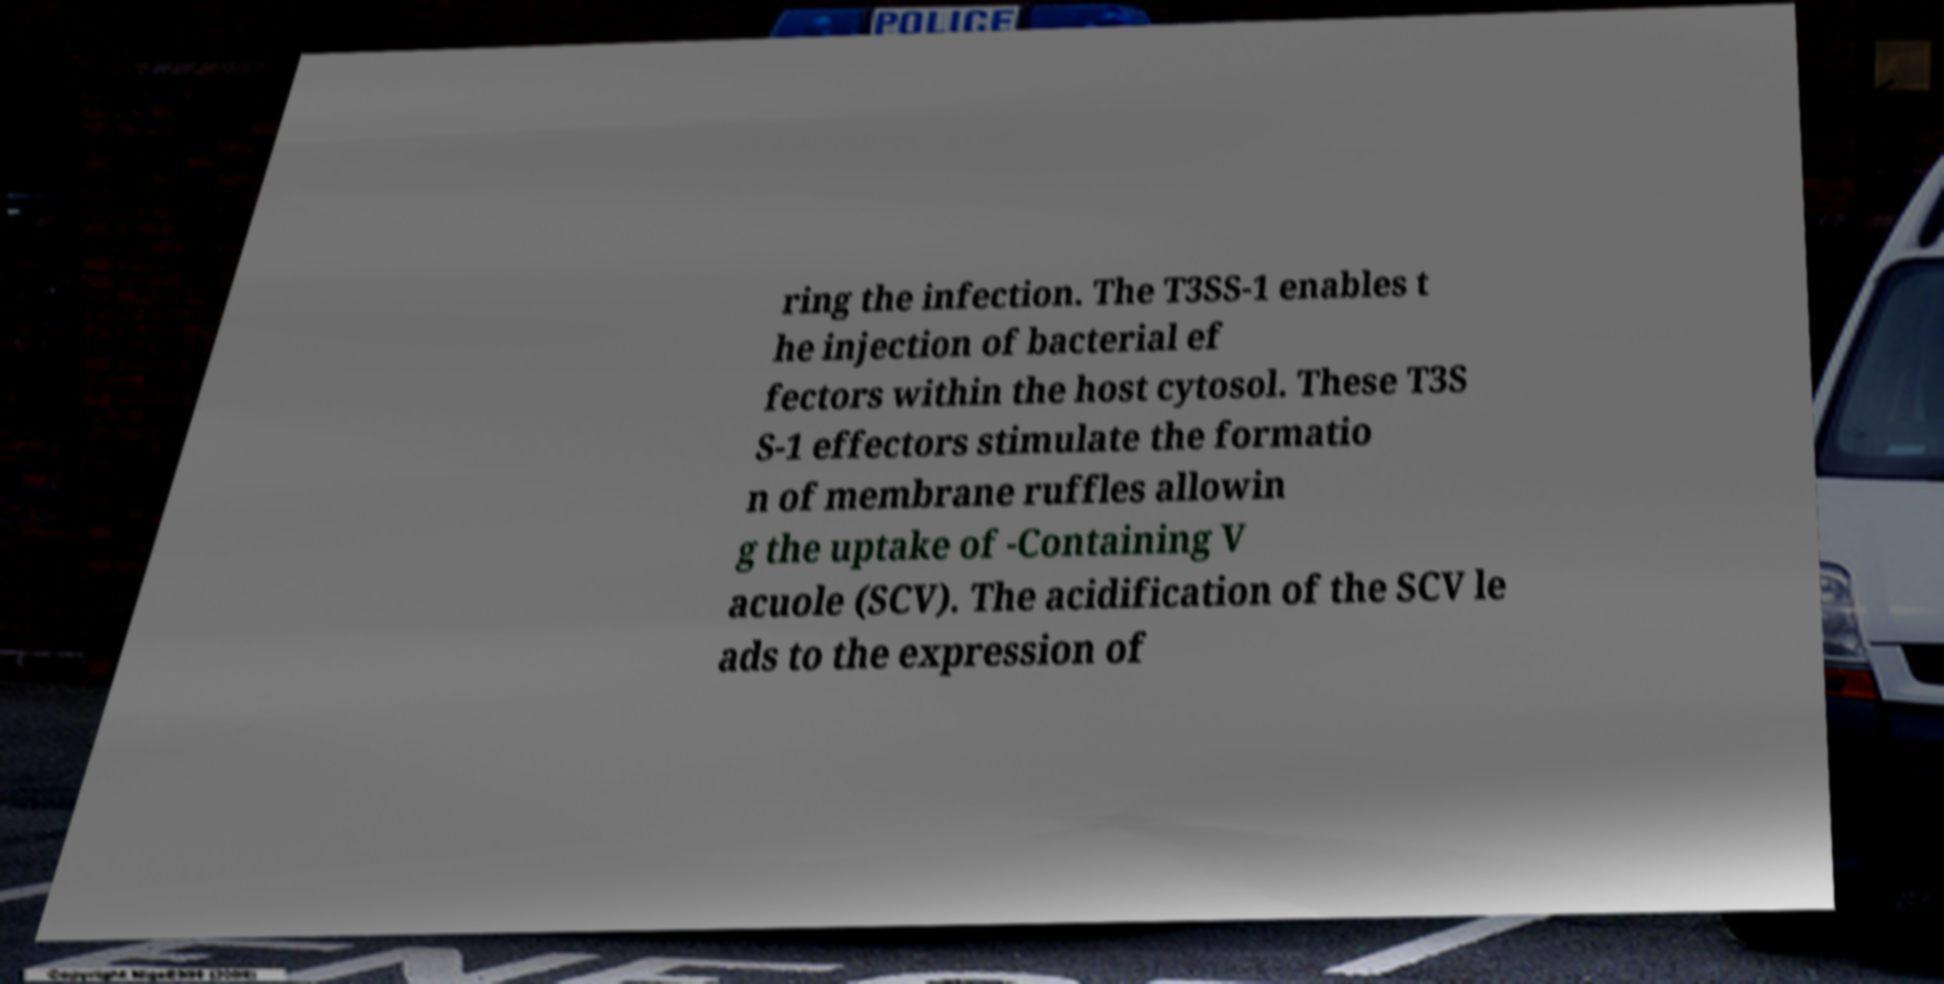I need the written content from this picture converted into text. Can you do that? ring the infection. The T3SS-1 enables t he injection of bacterial ef fectors within the host cytosol. These T3S S-1 effectors stimulate the formatio n of membrane ruffles allowin g the uptake of -Containing V acuole (SCV). The acidification of the SCV le ads to the expression of 